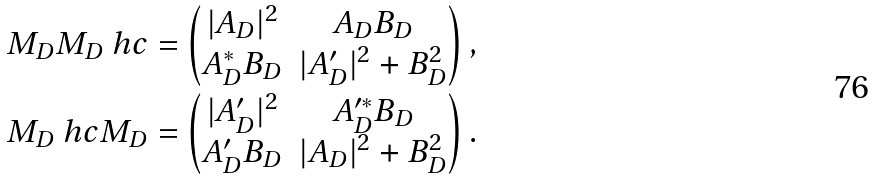<formula> <loc_0><loc_0><loc_500><loc_500>M _ { D } M _ { D } \ h c & = \begin{pmatrix} | A _ { D } | ^ { 2 } & A _ { D } B _ { D } \\ A _ { D } ^ { * } B _ { D } & | A _ { D } ^ { \prime } | ^ { 2 } + B _ { D } ^ { 2 } \end{pmatrix} , \\ M _ { D } \ h c M _ { D } & = \begin{pmatrix} | A _ { D } ^ { \prime } | ^ { 2 } & A _ { D } ^ { \prime * } B _ { D } \\ A _ { D } ^ { \prime } B _ { D } & | A _ { D } | ^ { 2 } + B _ { D } ^ { 2 } \end{pmatrix} .</formula> 